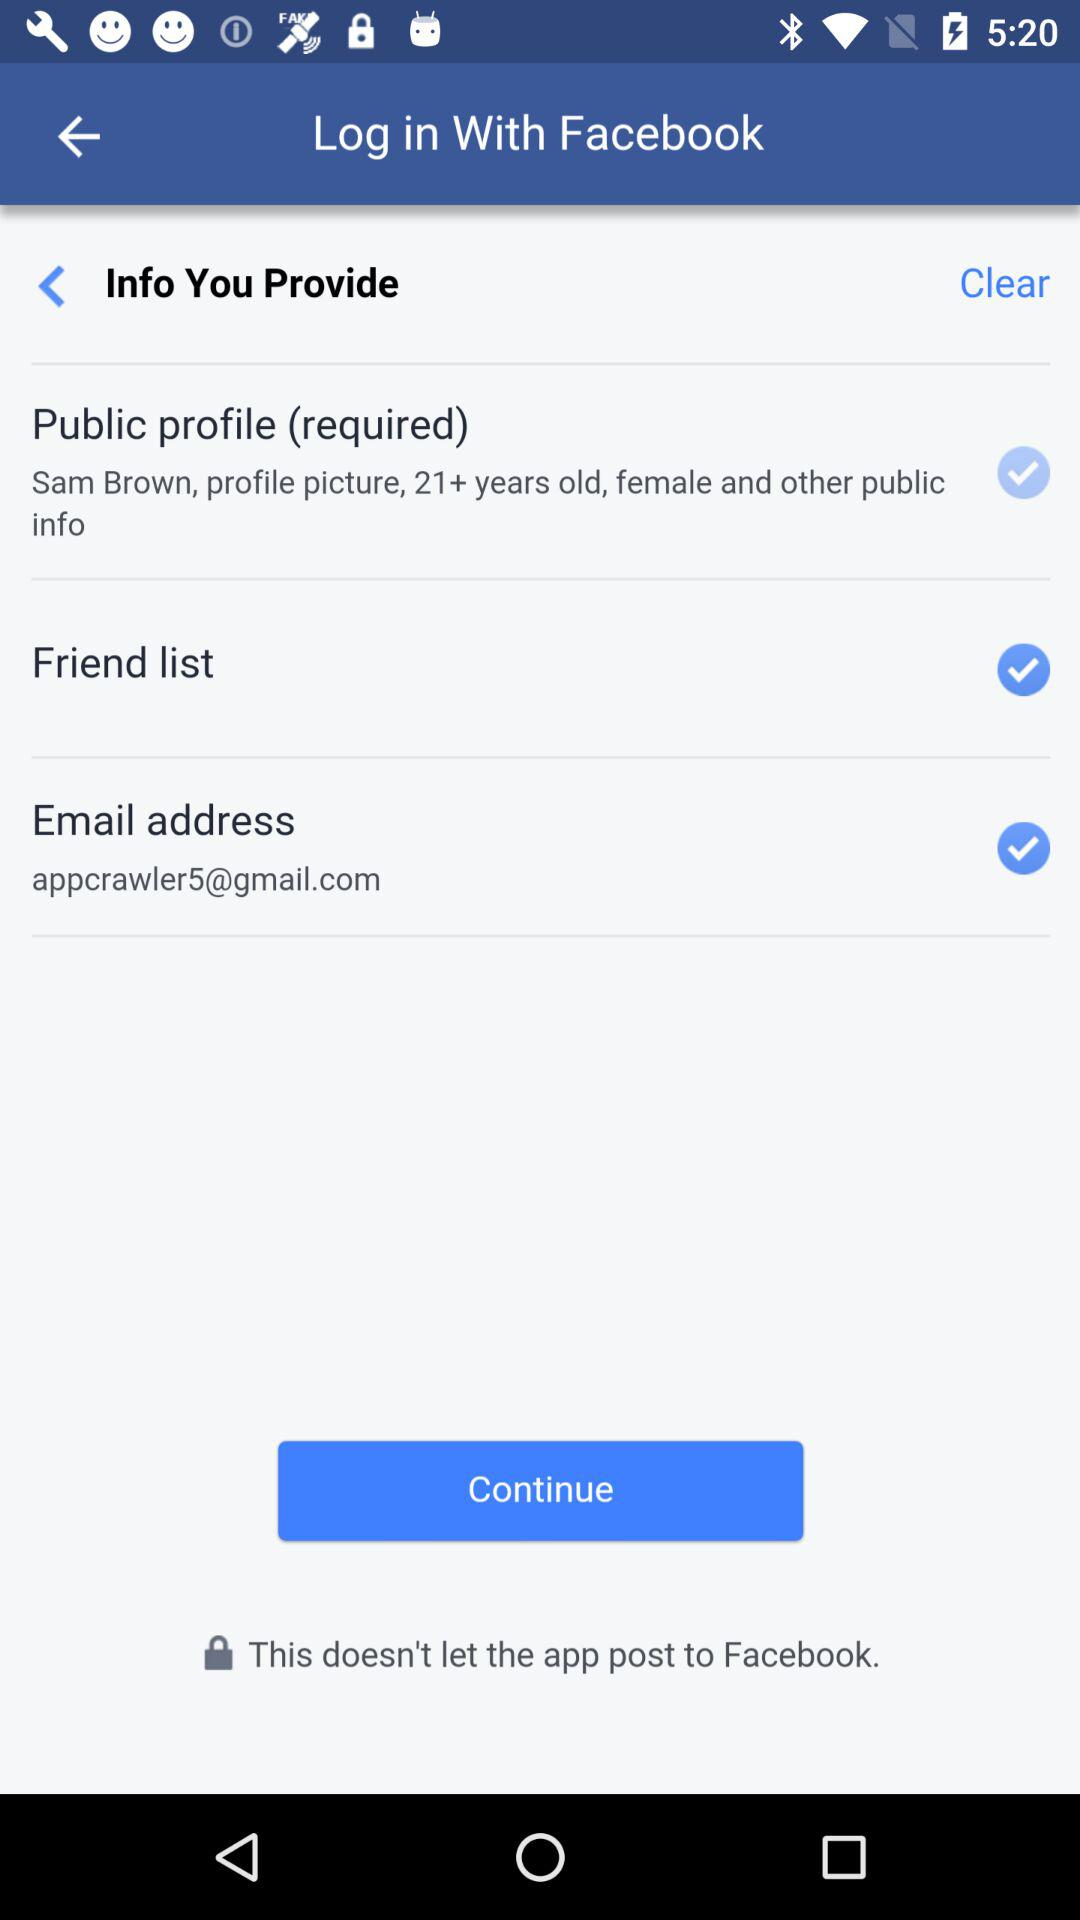What is the status of the "Friend list"? The status is "on". 